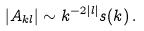<formula> <loc_0><loc_0><loc_500><loc_500>| A _ { k l } | \sim k ^ { - 2 | l | } s ( k ) \, .</formula> 